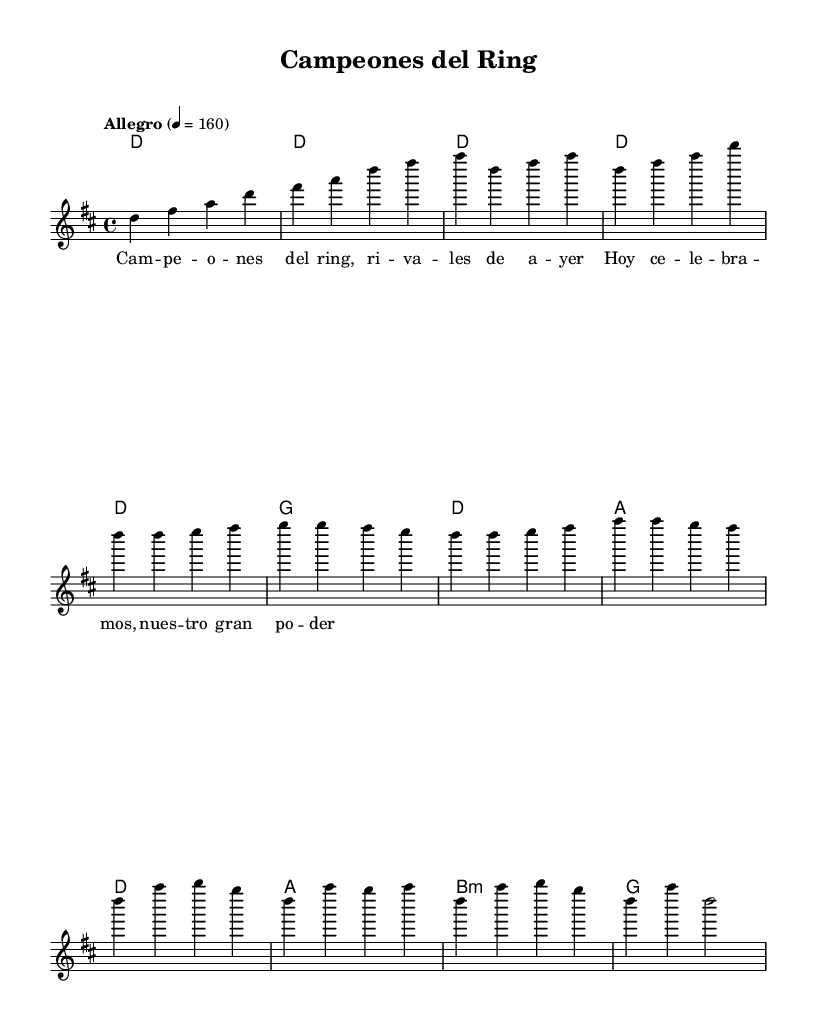What is the key signature of this music? The key signature is D major, which has two sharps: F sharp and C sharp.
Answer: D major What is the time signature of the piece? The time signature is listed as 4/4, indicating four beats per measure.
Answer: 4/4 What is the tempo marking for this music? The tempo marking shows "Allegro" with a metronome marking of 160 beats per minute, suggesting a lively pace.
Answer: Allegro What is the first note of the melody? The melody begins with the note D, which is indicated as the first note in the melody line.
Answer: D How many measures are in the chorus section? The chorus consists of four measures as indicated in the sheet music.
Answer: 4 Why is the title appropriate for this song? "Campeones del Ring" translates to "Champions of the Ring," suggesting a celebration of athletic achievement, which ties to the theme of athletic victories and rivalries throughout the song.
Answer: Celebration of athletic achievement What kind of chords are used in the harmony during the verse? The chords used are D, G, and A, which are typical in salsa music, contributing to the energetic and festive character.
Answer: D, G, A 